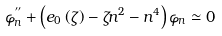Convert formula to latex. <formula><loc_0><loc_0><loc_500><loc_500>\varphi _ { n } ^ { ^ { \prime \prime } } + \left ( e _ { 0 } \left ( \zeta \right ) - \zeta n ^ { 2 } - n ^ { 4 } \right ) \varphi _ { n } \simeq 0</formula> 